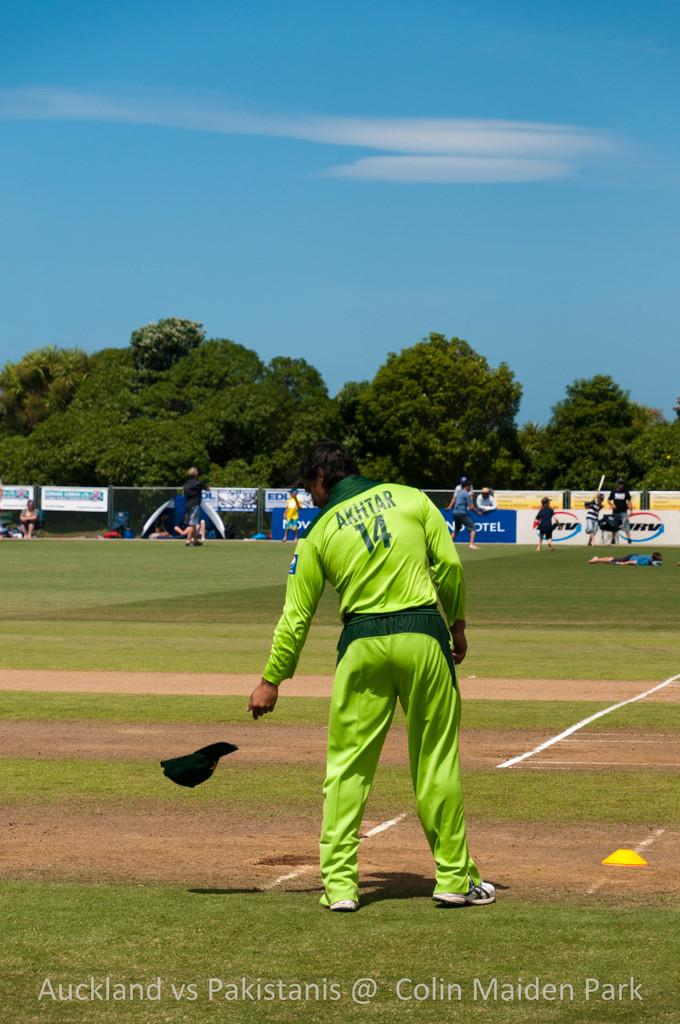<image>
Relay a brief, clear account of the picture shown. Akhtar, number 14, tossing his cap at game featuring Auckland vs Pakistanis 